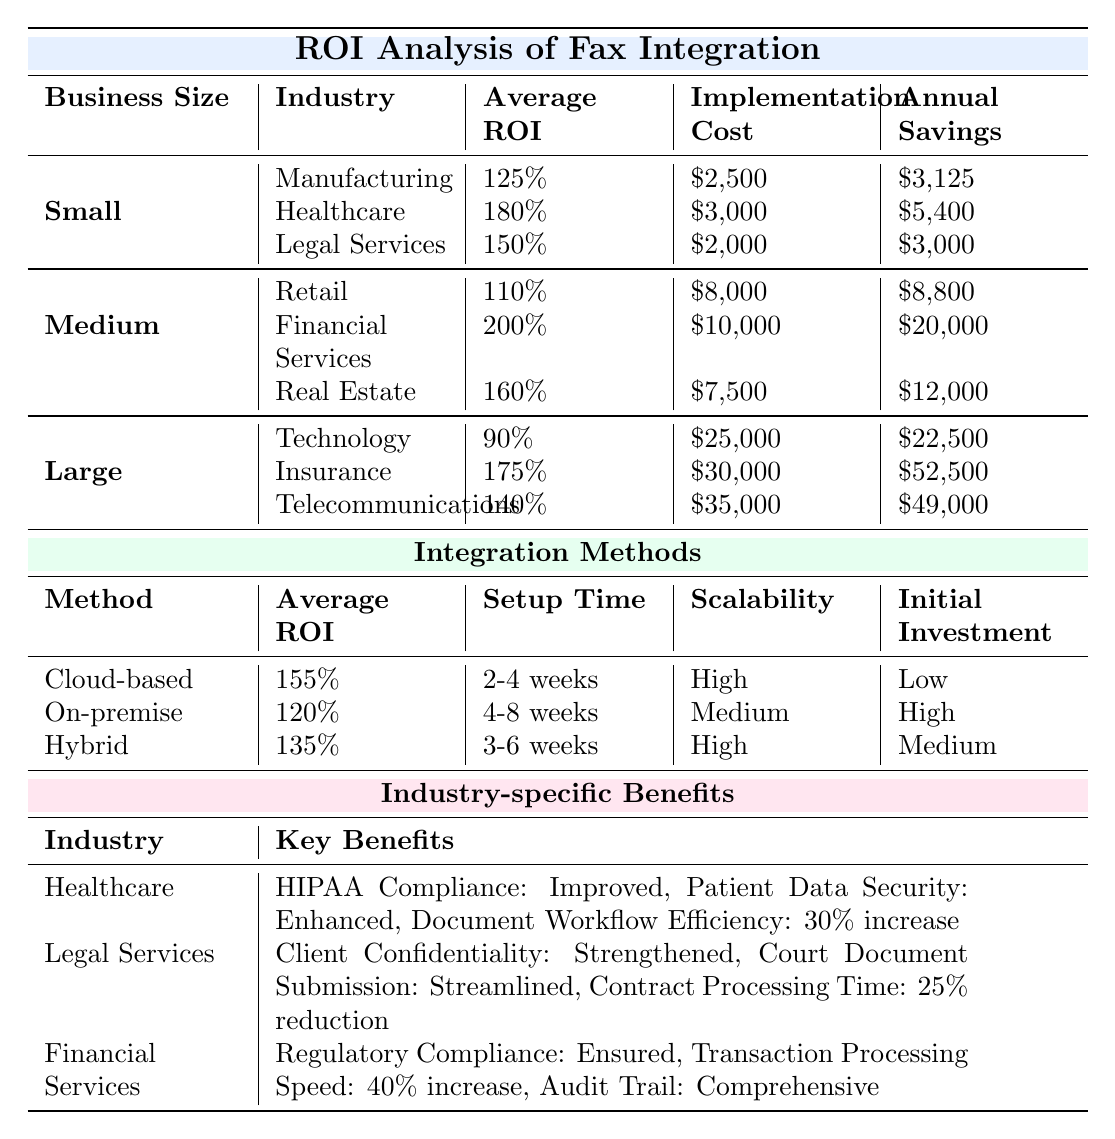What is the implementation cost for small manufacturing businesses? The table shows that the implementation cost for small businesses in manufacturing is listed as $2,500.
Answer: $2,500 Which business size has the highest average ROI among the healthcare industry? The average ROI for small healthcare businesses is 180%, while medium and large healthcare businesses are not listed in the table. Hence, small healthcare businesses have the highest average ROI among that sector.
Answer: 180% What is the average ROI for medium-sized retail businesses? The average ROI for medium-sized retail businesses is provided in the table as 110%.
Answer: 110% What is the payback period for integrating faxing solutions in legal services for small businesses? According to the table, the payback period for small businesses in legal services is 8 months.
Answer: 8 months Which integration method has the lowest average ROI? Looking at the integration methods section, the on-premise fax servers have the lowest average ROI at 120%.
Answer: 120% Considering all industries, which business size yields the highest annual savings from fax integration? The table lists the annual savings for large insurance businesses at $52,500, which is higher than any other industry or size listed.
Answer: $52,500 If a business decides to use a cloud-based fax service, what is the average ROI and what is the setup time? The cloud-based fax service has an average ROI of 155% and a setup time of 2-4 weeks as given in the respective section of the table.
Answer: 155%, 2-4 weeks How much more would a large telecommunications company save annually compared to a medium retail business? The annual savings for large telecommunications companies is $49,000, while for medium retail businesses it is $8,800. Calculating the difference: $49,000 - $8,800 = $40,200.
Answer: $40,200 Is there an industry where fax integration contributes to improved HIPAA compliance? Yes, according to the table, the healthcare industry benefits from improved HIPAA compliance with fax integration.
Answer: Yes Among the integration methods, which option requires the longest setup time? The setup time for on-premise fax servers is 4-8 weeks, which is longer than both cloud-based and hybrid solutions.
Answer: 4-8 weeks 